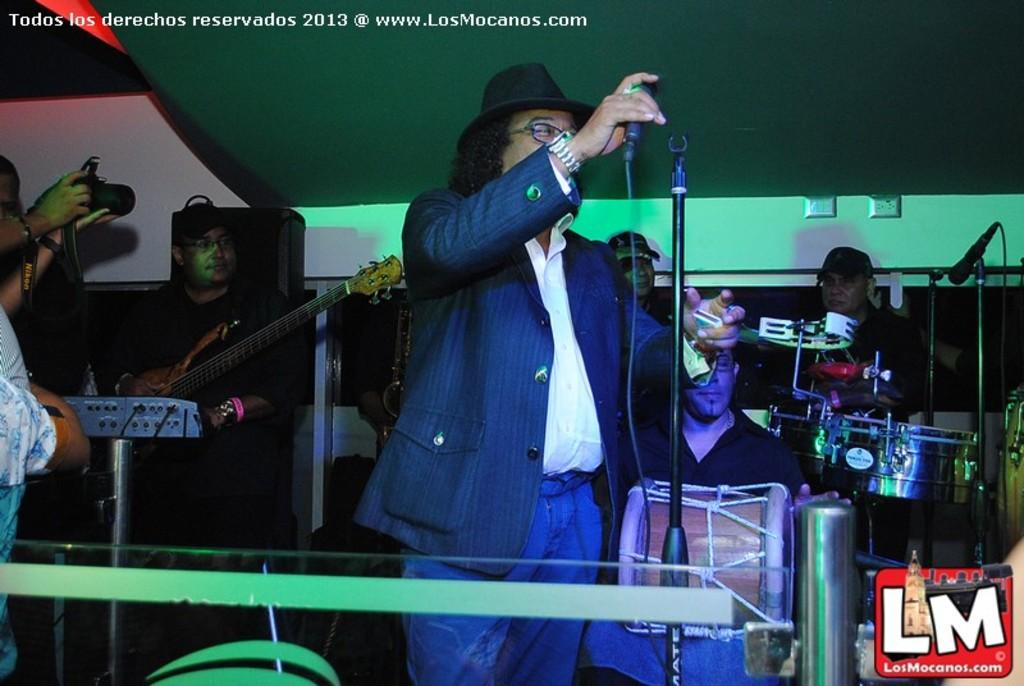What are the people in the image doing? The people in the image are standing on a stage and playing musical instruments. How are the people communicating with the audience? The people are holding microphones, which suggests they are using them to amplify their voices or instruments. What type of plants can be seen growing on the stage in the image? There are no plants visible on the stage in the image. What is the reaction of the laborer in the image? There is no laborer present in the image, so it is not possible to determine their reaction. 